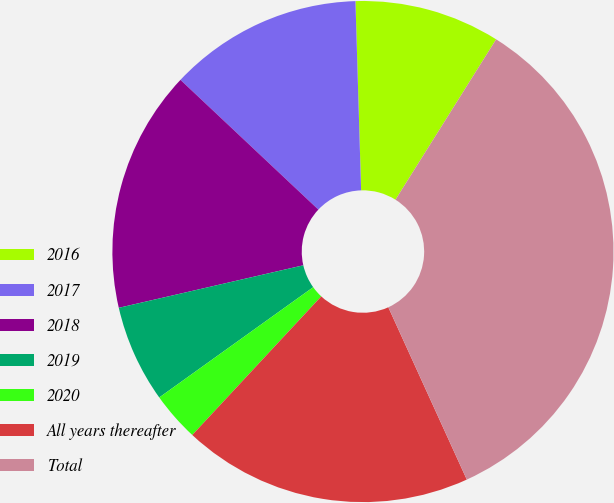Convert chart to OTSL. <chart><loc_0><loc_0><loc_500><loc_500><pie_chart><fcel>2016<fcel>2017<fcel>2018<fcel>2019<fcel>2020<fcel>All years thereafter<fcel>Total<nl><fcel>9.4%<fcel>12.51%<fcel>15.62%<fcel>6.29%<fcel>3.18%<fcel>18.73%<fcel>34.28%<nl></chart> 